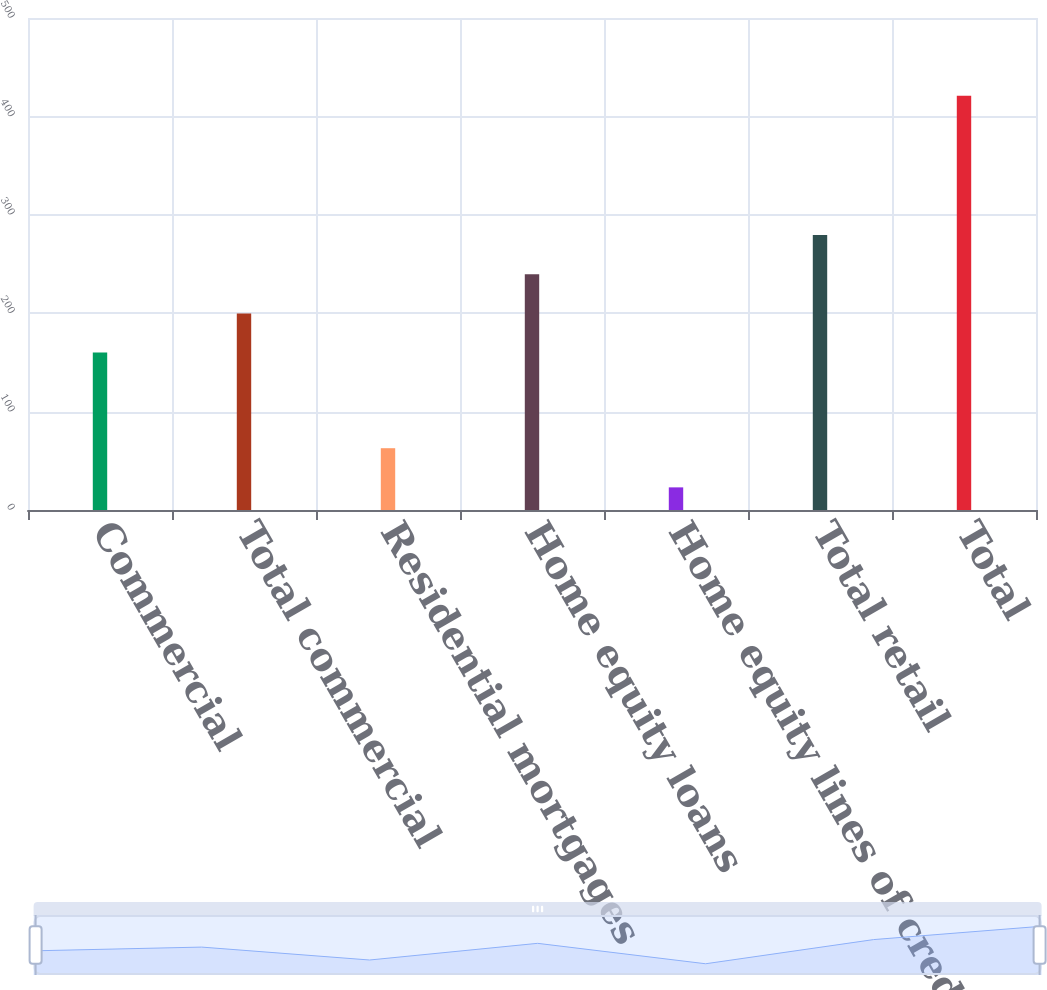<chart> <loc_0><loc_0><loc_500><loc_500><bar_chart><fcel>Commercial<fcel>Total commercial<fcel>Residential mortgages<fcel>Home equity loans<fcel>Home equity lines of credit<fcel>Total retail<fcel>Total<nl><fcel>160<fcel>199.8<fcel>62.8<fcel>239.6<fcel>23<fcel>279.4<fcel>421<nl></chart> 